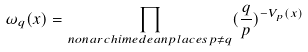<formula> <loc_0><loc_0><loc_500><loc_500>\omega _ { q } ( x ) = \prod _ { n o n a r c h i m e d e a n p l a c e s p \neq q } ( \frac { q } { p } ) ^ { - V _ { p } ( x ) }</formula> 